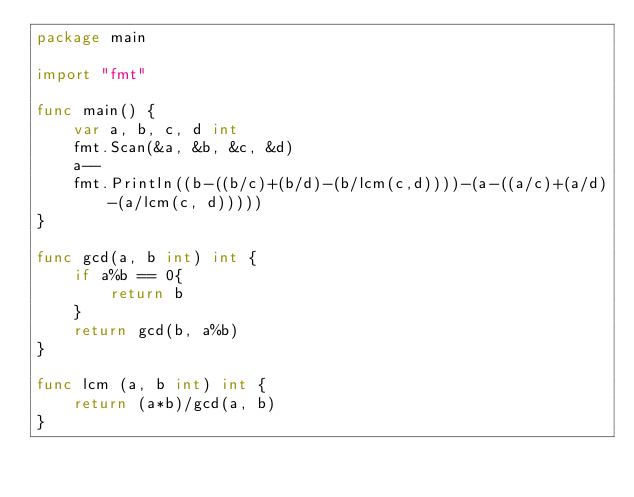<code> <loc_0><loc_0><loc_500><loc_500><_Go_>package main

import "fmt"

func main() {
	var a, b, c, d int
	fmt.Scan(&a, &b, &c, &d)
	a--
	fmt.Println((b-((b/c)+(b/d)-(b/lcm(c,d))))-(a-((a/c)+(a/d)-(a/lcm(c, d)))))
}

func gcd(a, b int) int {
	if a%b == 0{
		return b
	}
	return gcd(b, a%b)
}

func lcm (a, b int) int {
	return (a*b)/gcd(a, b)
}</code> 